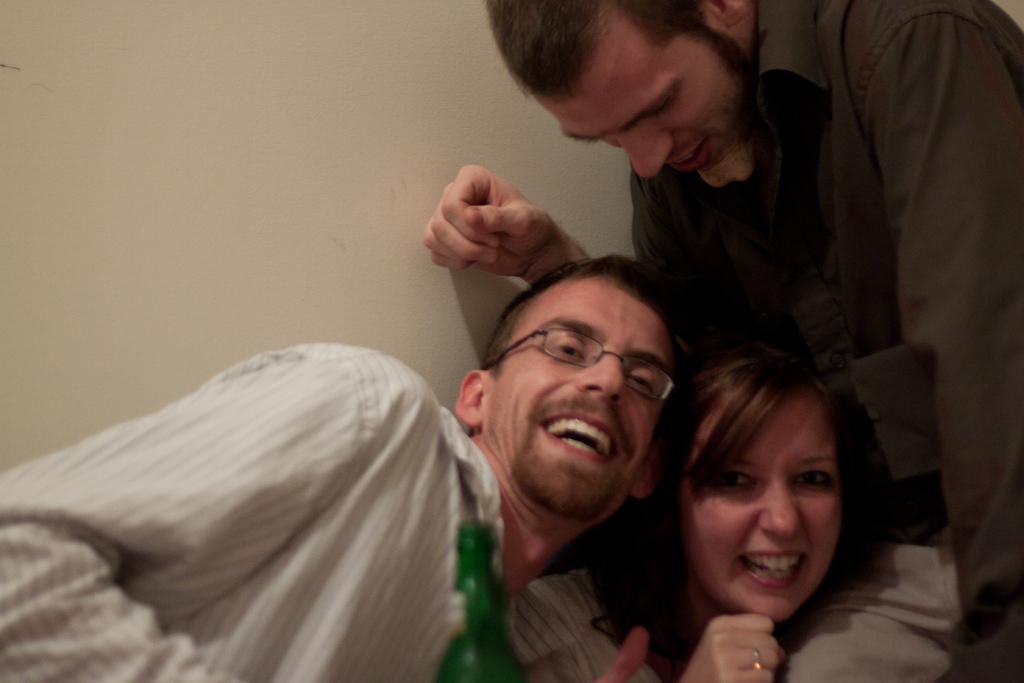How would you summarize this image in a sentence or two? In the picture there are three people, three of them are laughing. There is a bottle in front of the first person. In the background there is a wall. 